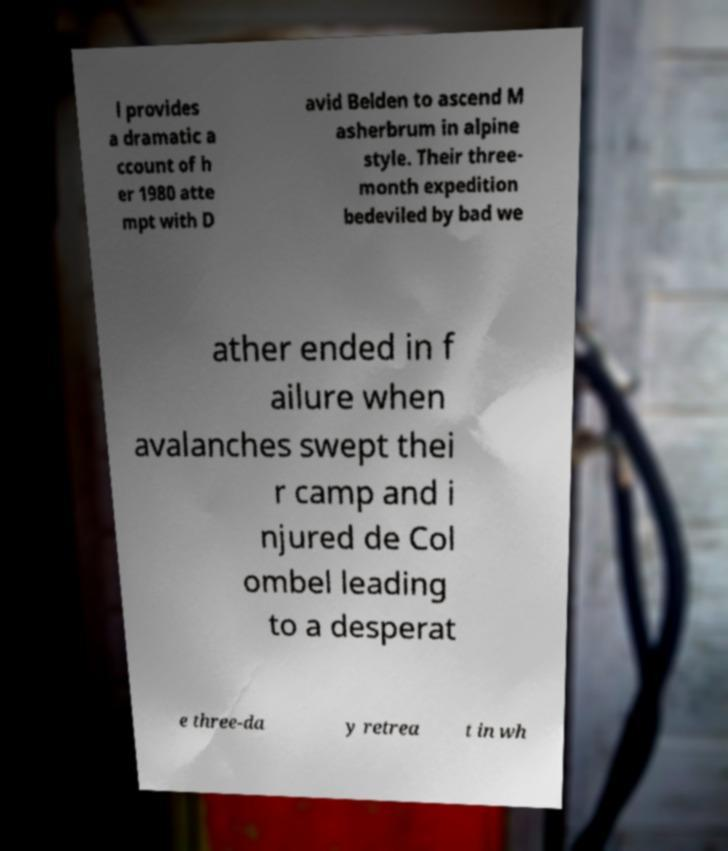Can you read and provide the text displayed in the image?This photo seems to have some interesting text. Can you extract and type it out for me? l provides a dramatic a ccount of h er 1980 atte mpt with D avid Belden to ascend M asherbrum in alpine style. Their three- month expedition bedeviled by bad we ather ended in f ailure when avalanches swept thei r camp and i njured de Col ombel leading to a desperat e three-da y retrea t in wh 